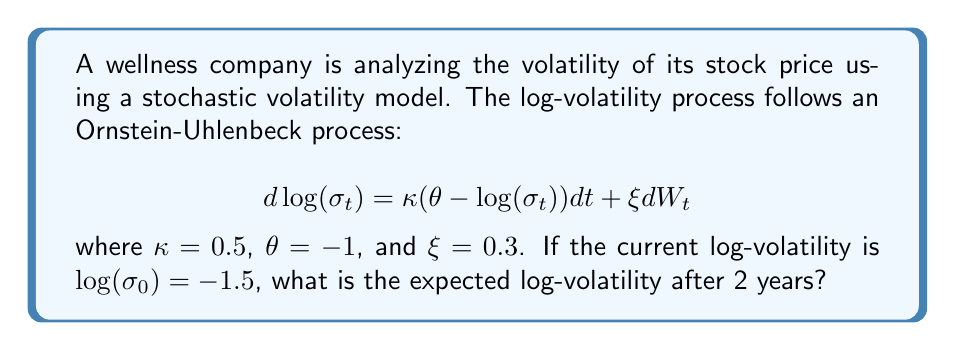Provide a solution to this math problem. To solve this problem, we need to use the properties of the Ornstein-Uhlenbeck process:

1) For an Ornstein-Uhlenbeck process of the form:
   $$ dX_t = \kappa(\theta - X_t)dt + \xi dW_t $$

   The expected value at time t, given the initial value $X_0$, is:
   $$ E[X_t|X_0] = \theta + (X_0 - \theta)e^{-\kappa t} $$

2) In our case:
   - $X_t = \log(\sigma_t)$
   - $X_0 = \log(\sigma_0) = -1.5$
   - $\kappa = 0.5$
   - $\theta = -1$
   - $t = 2$ years

3) Substituting these values into the formula:
   $$ E[\log(\sigma_2)|\log(\sigma_0)] = -1 + (-1.5 - (-1))e^{-0.5 \cdot 2} $$

4) Simplify:
   $$ = -1 + (-0.5)e^{-1} $$
   $$ = -1 - 0.5 \cdot \frac{1}{e} $$
   $$ = -1 - \frac{0.5}{2.718281828} $$
   $$ \approx -1.184 $$

Therefore, the expected log-volatility after 2 years is approximately -1.184.
Answer: -1.184 